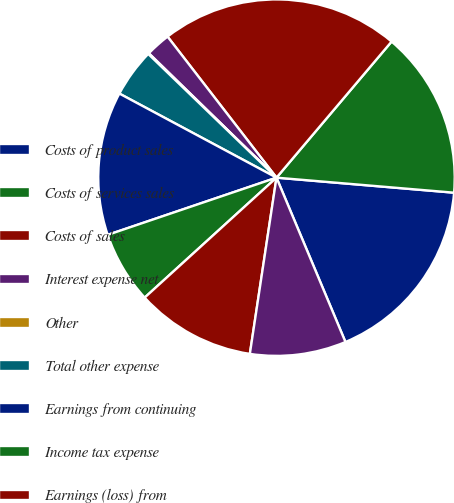Convert chart. <chart><loc_0><loc_0><loc_500><loc_500><pie_chart><fcel>Costs of product sales<fcel>Costs of services sales<fcel>Costs of sales<fcel>Interest expense net<fcel>Other<fcel>Total other expense<fcel>Earnings from continuing<fcel>Income tax expense<fcel>Earnings (loss) from<fcel>Net earnings (loss)<nl><fcel>17.33%<fcel>15.17%<fcel>21.64%<fcel>2.24%<fcel>0.08%<fcel>4.39%<fcel>13.02%<fcel>6.55%<fcel>10.86%<fcel>8.71%<nl></chart> 